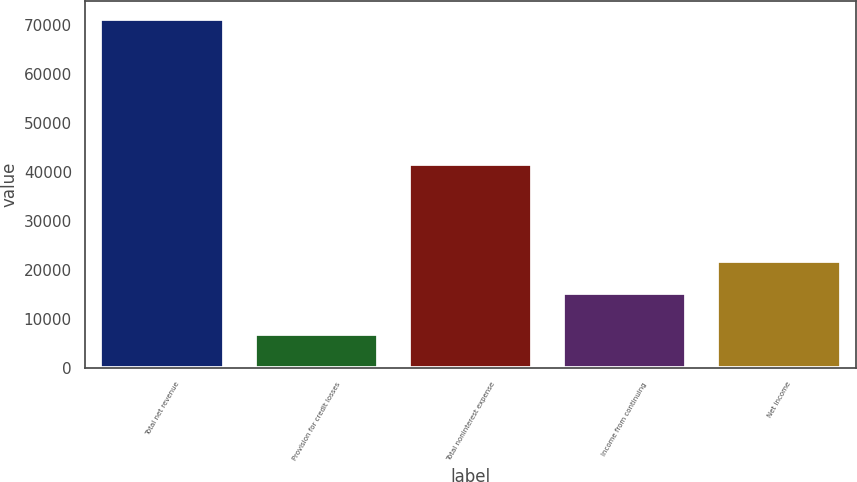Convert chart to OTSL. <chart><loc_0><loc_0><loc_500><loc_500><bar_chart><fcel>Total net revenue<fcel>Provision for credit losses<fcel>Total noninterest expense<fcel>Income from continuing<fcel>Net income<nl><fcel>71372<fcel>6864<fcel>41703<fcel>15365<fcel>21815.8<nl></chart> 